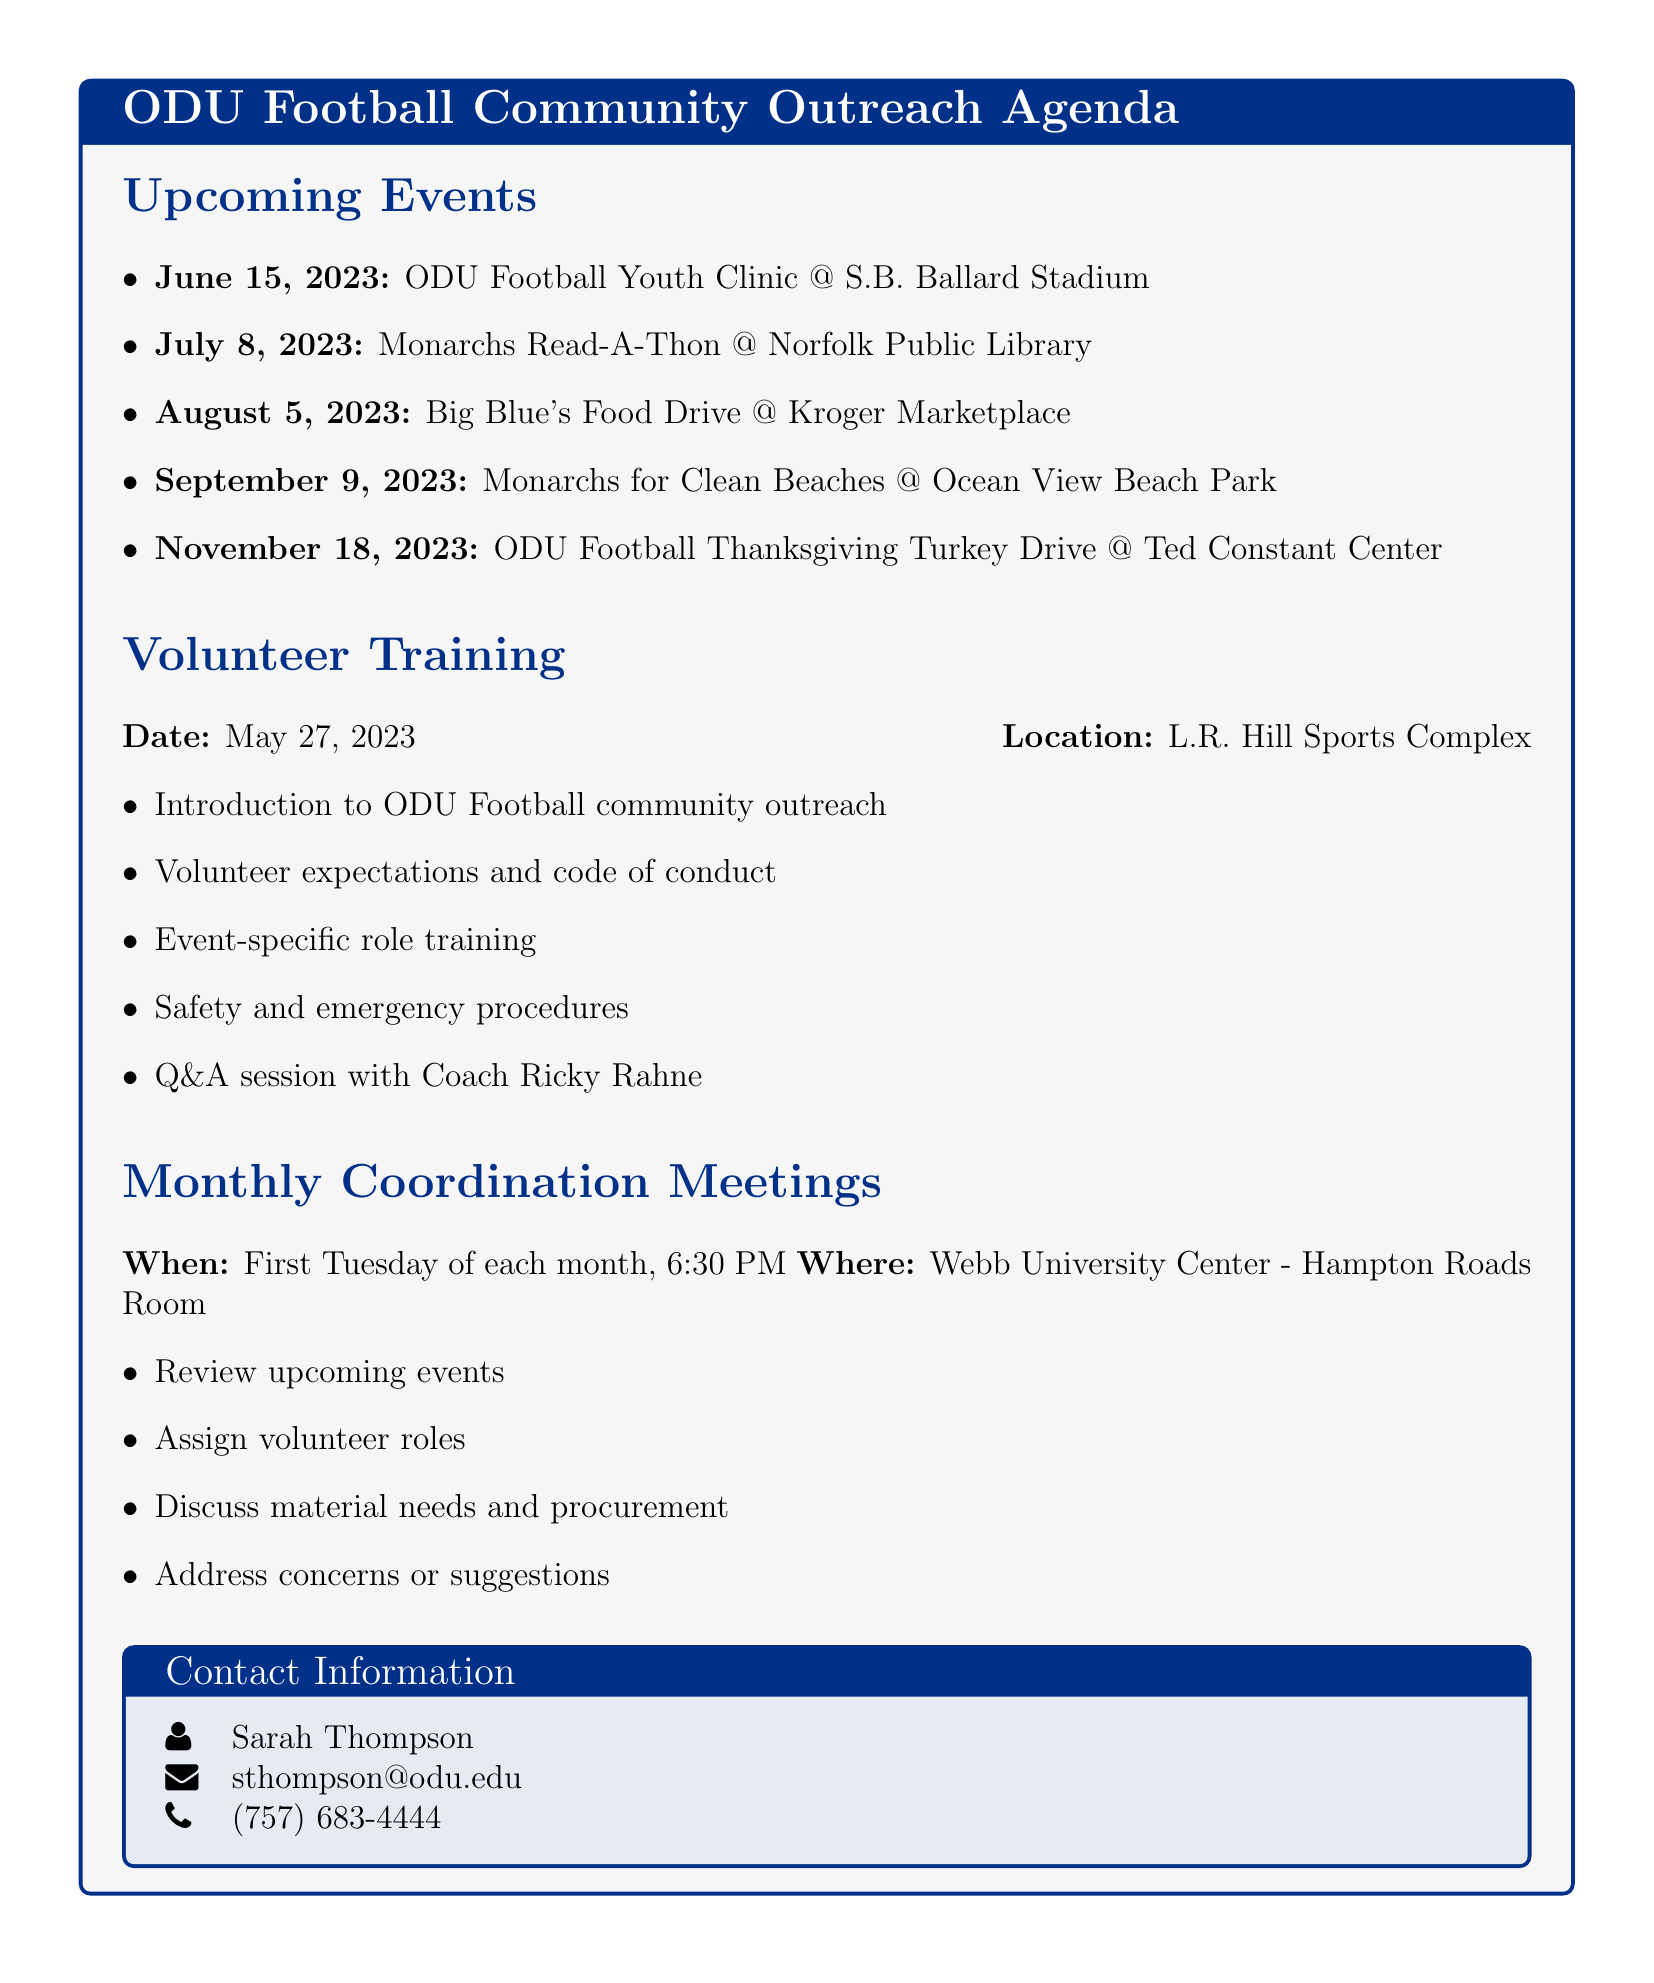What is the date of the ODU Football Youth Clinic? The date for the ODU Football Youth Clinic can be found in the upcoming events section, listed as June 15, 2023.
Answer: June 15, 2023 Where will the Monarchs Read-A-Thon take place? The location for the Monarchs Read-A-Thon is specified in the upcoming events section, which is the Norfolk Public Library - Main Branch.
Answer: Norfolk Public Library - Main Branch What materials are required for the Big Blue's Food Drive? Required materials for the Big Blue's Food Drive can be found in the event details and include collection boxes, ODU Football flyers, donation lists, and team mascot costume.
Answer: Collection boxes, ODU Football flyers, donation lists, team mascot costume Who is the main contact for the community outreach program? The main contact information including the name can be found in the document, indicating Sarah Thompson.
Answer: Sarah Thompson What is discussed during the monthly coordination meetings? The agenda for the monthly coordination meetings specifies topics discussed including reviewing upcoming events and assigning volunteer roles.
Answer: Review upcoming events, assign volunteer roles, discuss material needs and procurement, address concerns or suggestions When is the volunteer training session scheduled? The volunteer training date is clearly stated in the document under the Volunteer Training section, which is May 27, 2023.
Answer: May 27, 2023 What volunteer role is needed for the ODU Football Thanksgiving Turkey Drive? The roles required for the ODU Football Thanksgiving Turkey Drive are listed under the event details, stating traffic directors, turkey distributors, food box packers, recipient check-in.
Answer: Traffic directors, turkey distributors, food box packers, recipient check-in How often do the coordination meetings occur? The frequency of the coordination meetings is explicitly mentioned as the first Tuesday of each month.
Answer: First Tuesday of each month 